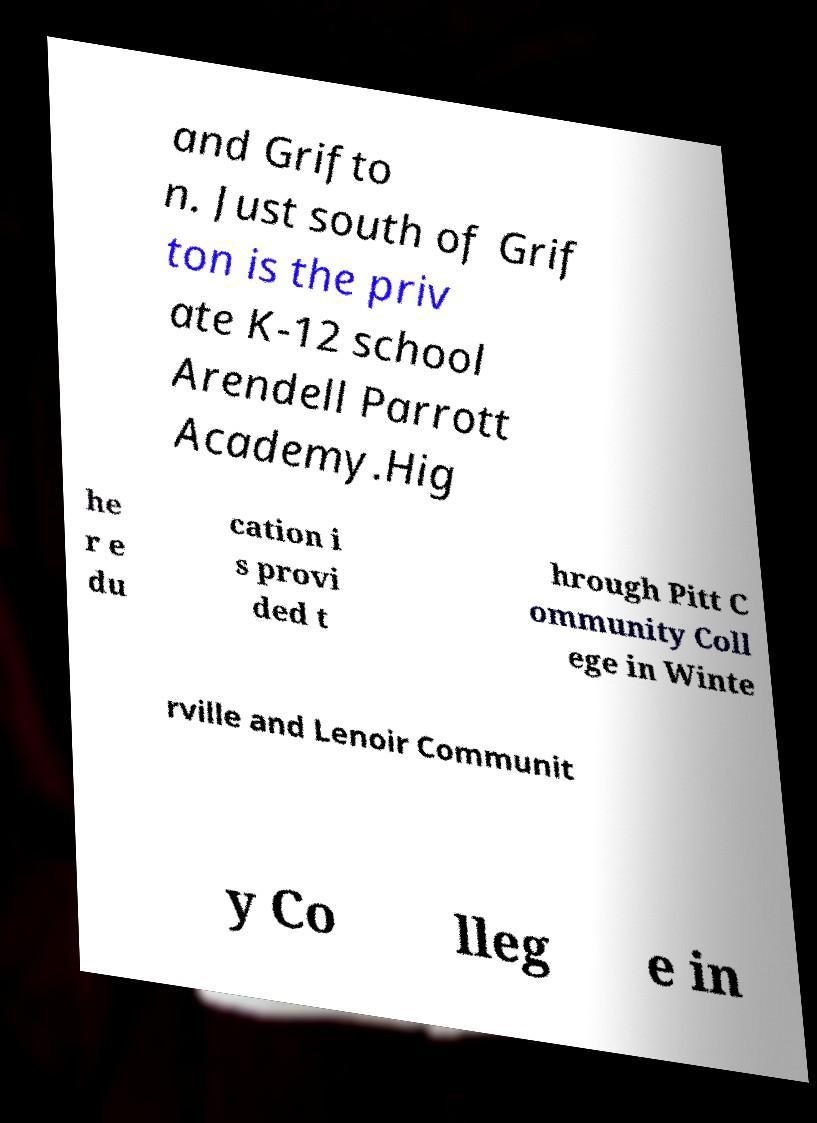I need the written content from this picture converted into text. Can you do that? and Grifto n. Just south of Grif ton is the priv ate K-12 school Arendell Parrott Academy.Hig he r e du cation i s provi ded t hrough Pitt C ommunity Coll ege in Winte rville and Lenoir Communit y Co lleg e in 